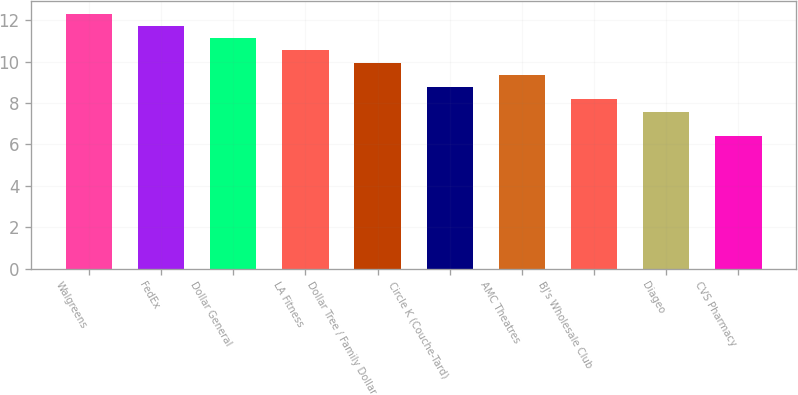<chart> <loc_0><loc_0><loc_500><loc_500><bar_chart><fcel>Walgreens<fcel>FedEx<fcel>Dollar General<fcel>LA Fitness<fcel>Dollar Tree / Family Dollar<fcel>Circle K (Couche-Tard)<fcel>AMC Theatres<fcel>BJ's Wholesale Club<fcel>Diageo<fcel>CVS Pharmacy<nl><fcel>12.31<fcel>11.72<fcel>11.13<fcel>10.54<fcel>9.95<fcel>8.77<fcel>9.36<fcel>8.18<fcel>7.59<fcel>6.41<nl></chart> 